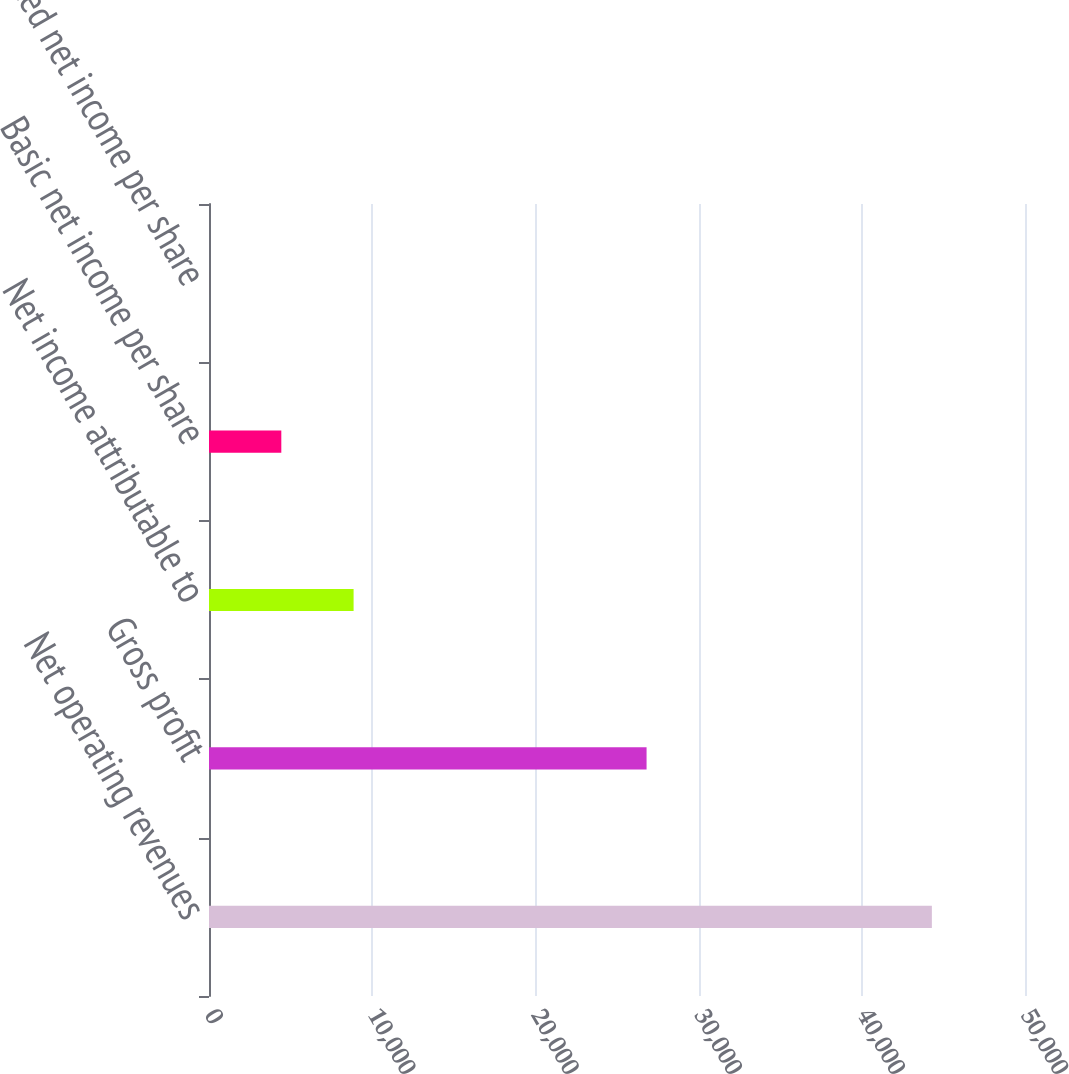Convert chart. <chart><loc_0><loc_0><loc_500><loc_500><bar_chart><fcel>Net operating revenues<fcel>Gross profit<fcel>Net income attributable to<fcel>Basic net income per share<fcel>Diluted net income per share<nl><fcel>44294<fcel>26812<fcel>8860.13<fcel>4430.9<fcel>1.67<nl></chart> 